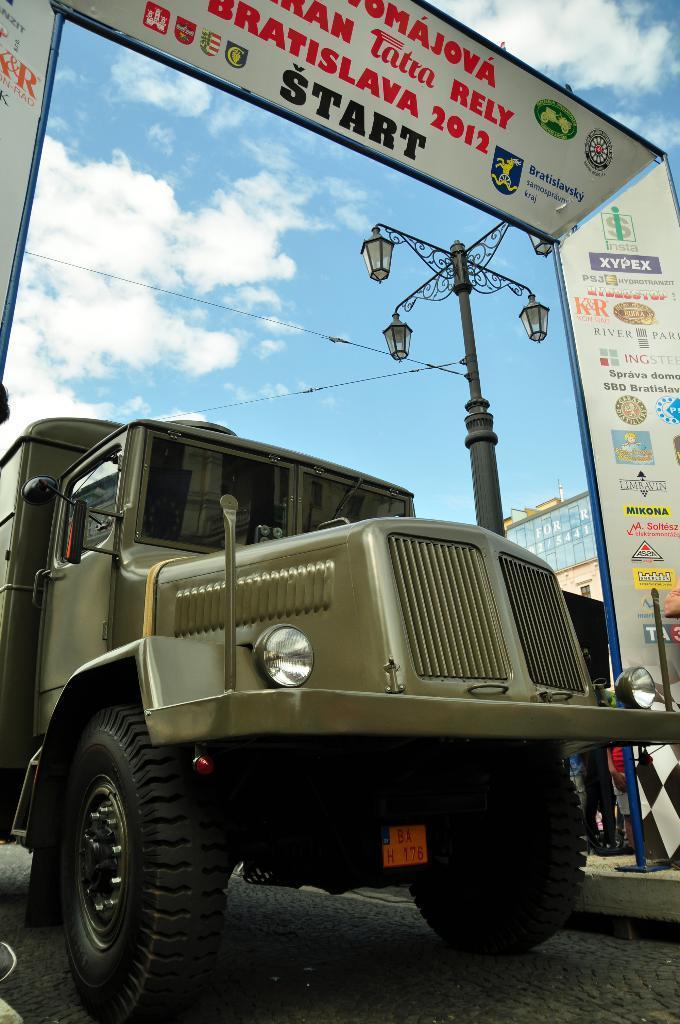How would you summarize this image in a sentence or two? In the picture we can see a truck, which is dark green in color and behind it, we can see an entrance gateway and behind it, we can see a pole with lights and in the background we can see a sky with clouds. 